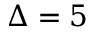Convert formula to latex. <formula><loc_0><loc_0><loc_500><loc_500>\Delta = 5</formula> 